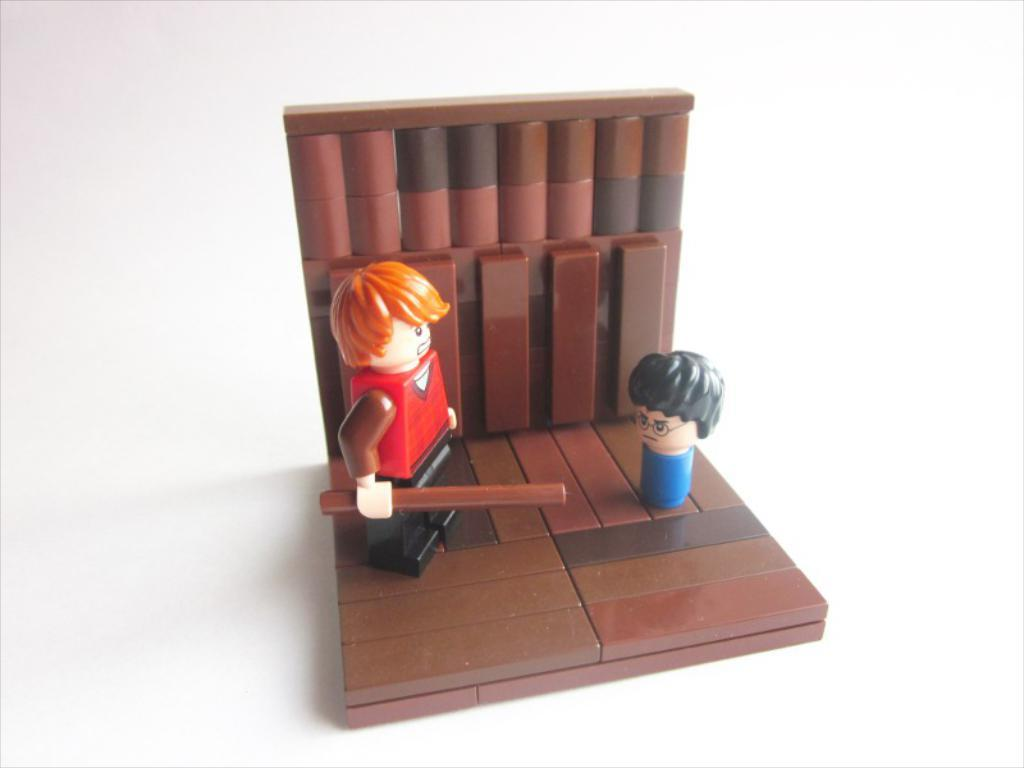What type of toy is featured in the image? There is a toy made up of blocks in the image. Are there any other toys present in the image? Yes, there are two toys on the blocks. What is one of the toys holding? One of the toys is holding a lock. How many legs can be seen on the toys in the image? There is no information about the number of legs on the toys in the image, as the toys are likely made of blocks and do not have legs. 